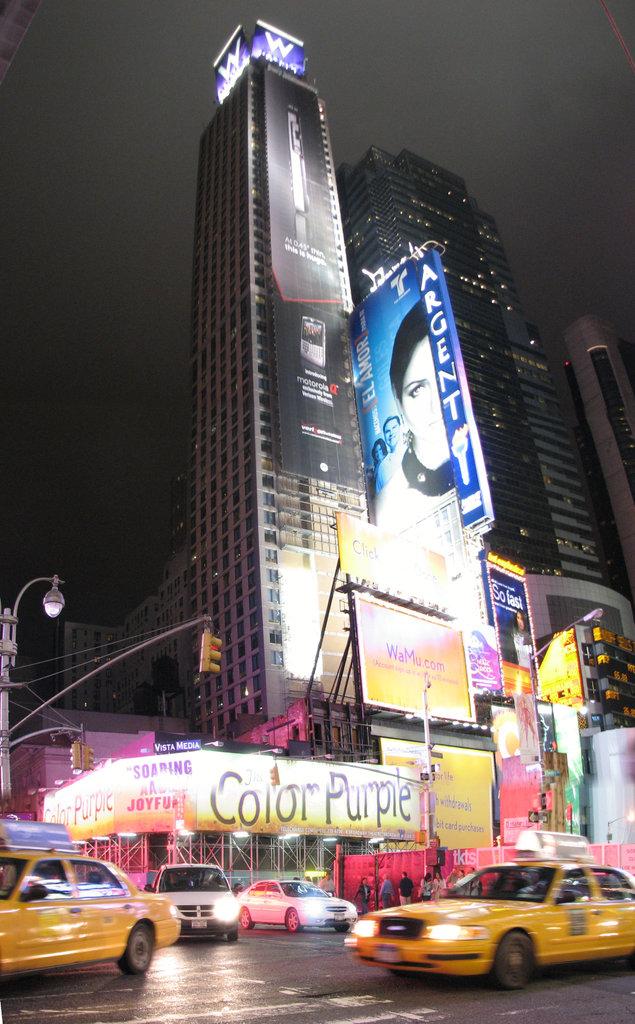What is on the yellow banner?
Offer a very short reply. Color purple. What company is advertising on the blue sign, written vertically?
Make the answer very short. Argent. 